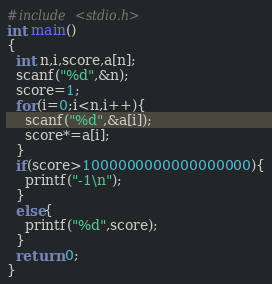<code> <loc_0><loc_0><loc_500><loc_500><_C_>#include <stdio.h>
int main()
{
  int n,i,score,a[n];
  scanf("%d",&n);
  score=1;
  for(i=0;i<n,i++){
    scanf("%d",&a[i]);
    score*=a[i];
  }
  if(score>1000000000000000000){
    printf("-1\n");
  }
  else{
    printf("%d",score);
  }
  return 0;
}</code> 